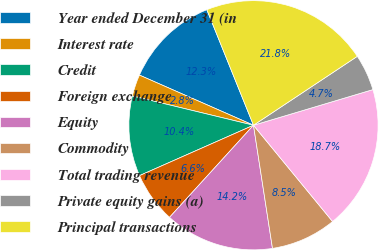<chart> <loc_0><loc_0><loc_500><loc_500><pie_chart><fcel>Year ended December 31 (in<fcel>Interest rate<fcel>Credit<fcel>Foreign exchange<fcel>Equity<fcel>Commodity<fcel>Total trading revenue<fcel>Private equity gains (a)<fcel>Principal transactions<nl><fcel>12.3%<fcel>2.82%<fcel>10.4%<fcel>6.61%<fcel>14.2%<fcel>8.51%<fcel>18.67%<fcel>4.71%<fcel>21.78%<nl></chart> 